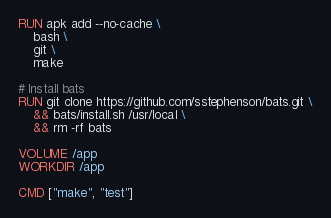Convert code to text. <code><loc_0><loc_0><loc_500><loc_500><_Dockerfile_>RUN apk add --no-cache \
    bash \
    git \
    make 

# Install bats
RUN git clone https://github.com/sstephenson/bats.git \
    && bats/install.sh /usr/local \
    && rm -rf bats

VOLUME /app
WORKDIR /app

CMD ["make", "test"]
</code> 